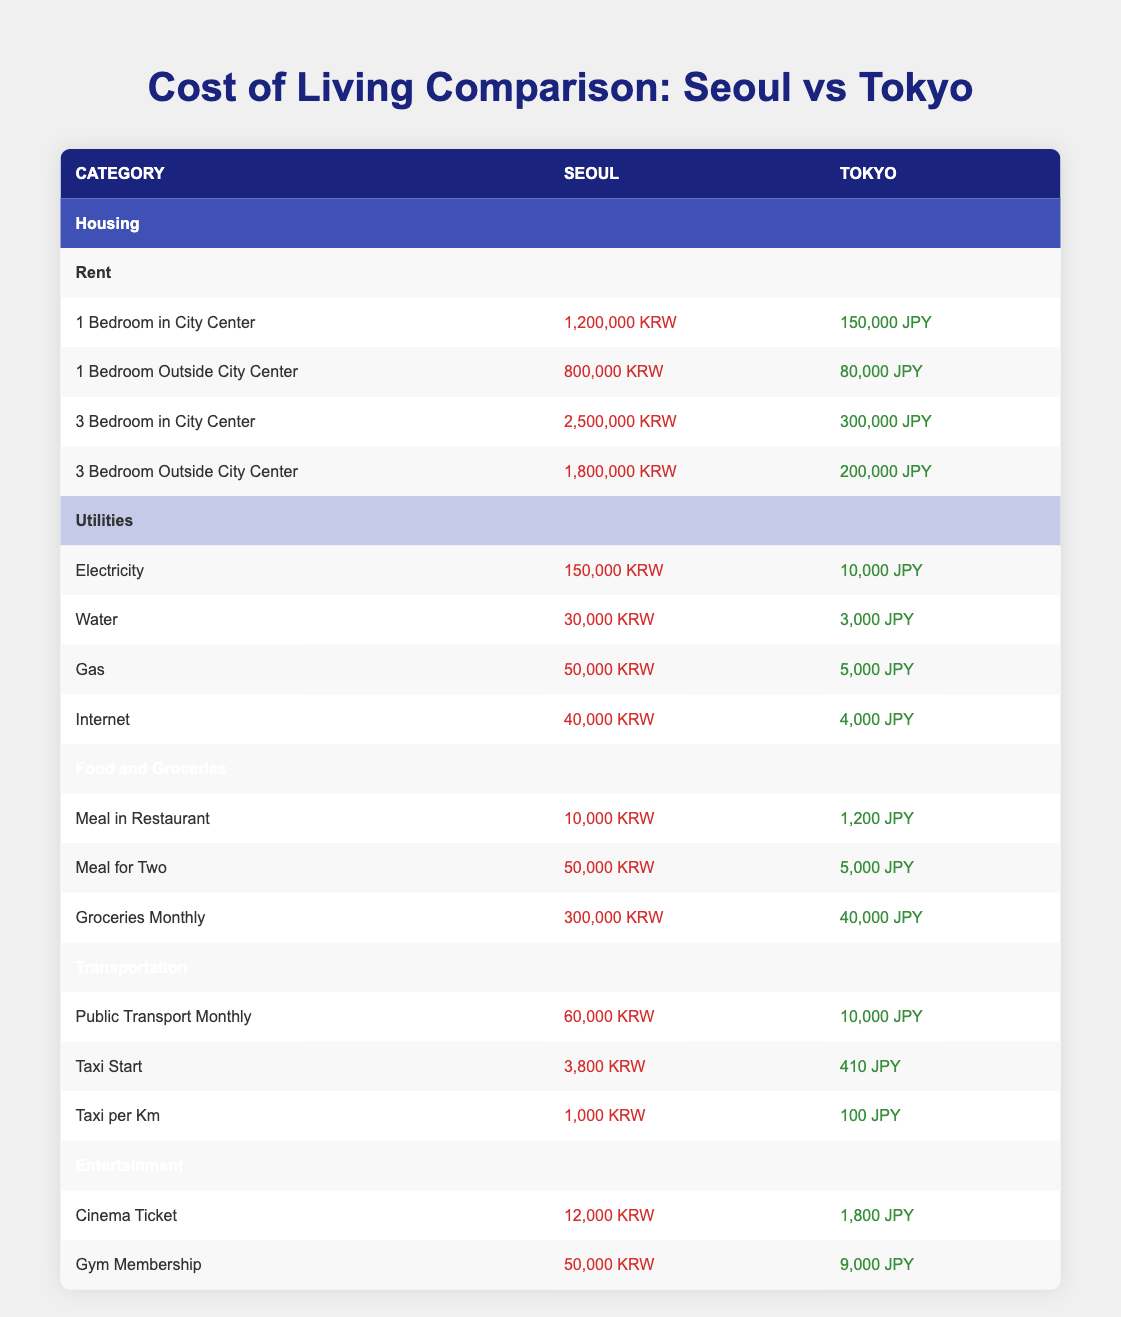What is the rent for a 1-bedroom apartment in the city center of Seoul? According to the table, the rent for a 1-bedroom apartment in the city center of Seoul is listed as 1,200,000 KRW.
Answer: 1,200,000 KRW How much does utilities cost in Seoul compared to Tokyo? The total cost of utilities in Seoul (Electricity + Water + Gas + Internet) is 150,000 + 30,000 + 50,000 + 40,000 = 270,000 KRW. In Tokyo, the total utilities cost is 10,000 + 3,000 + 5,000 + 4,000 = 22,000 JPY.
Answer: 270,000 KRW vs 22,000 JPY Is the public transport monthly cost higher in Seoul than in Tokyo? The monthly cost for public transport in Seoul is 60,000 KRW, while in Tokyo it is 10,000 JPY. To answer the question, we compare the two values directly. The KRW amount is greater than the JPY amount, but conversion rates have to be considered for absolute comparison. However, based on the table alone, Seoul's public transport cost appears higher.
Answer: Yes What is the difference in cost between a meal for two in Seoul and Tokyo? The cost of a meal for two in Seoul is 50,000 KRW, while in Tokyo it is 5,000 JPY. To determine the difference, we can convert both currencies into a single currency or compare them directly. If considering a direct comparison, it can be noted that initially 50,000 KRW is greater than 5,000 JPY, but it requires conversion for an exact number.
Answer: 50,000 KRW > 5,000 JPY Which is cheaper, the cinema ticket in Seoul or Tokyo, and by how much? The cinema ticket in Seoul costs 12,000 KRW, while in Tokyo it is 1,800 JPY. To determine the difference, one must convert either currency or directly compare them. Without conversion, it is clear the ticket price is higher in Seoul. For conversion, if we had the exchange rate, we could say how much cheaper Tokyo is, but based on visual comparison, less is directly noted.
Answer: 12,000 KRW > 1,800 JPY What do the monthly transportation costs for Seoul and Tokyo indicate about their public transport pricing? The monthly transportation cost for Seoul is 60,000 KRW, and for Tokyo, it is 10,000 JPY. This indicates that Seoul’s public transport costs significantly more than Tokyo’s in a direct visual comparison, although the conversion would provide more accurate figures. Generally, this implies Seoul has higher pricing for public transport overall.
Answer: Seoul's cost is higher Is it true that groceries monthly cost in Tokyo is lower than in Seoul? In Seoul, groceries monthly cost is 300,000 KRW, while in Tokyo it is 40,000 JPY. A direct comparison shows that without conversion, 300,000 KRW appears higher than 40,000 JPY, making it clear groceries cost more in Seoul.
Answer: No If someone is living in Tokyo and wants to go to the gym, which city offers a cheaper gym membership? Tokyo's gym membership is 9,000 JPY, while Seoul's is 50,000 KRW. A visual comparison shows that 9,000 JPY (if converted properly) is likely cheaper than 50,000 KRW, indicating that living in Tokyo provides cheaper options for gym access.
Answer: Tokyo is cheaper 